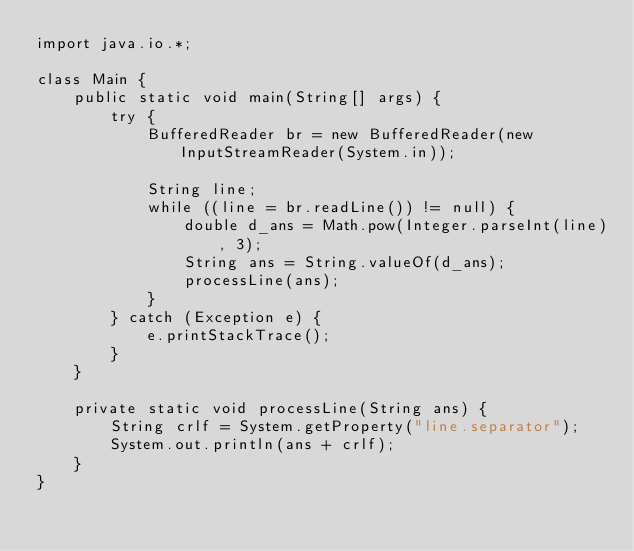Convert code to text. <code><loc_0><loc_0><loc_500><loc_500><_Java_>import java.io.*;

class Main {
    public static void main(String[] args) {
        try {
            BufferedReader br = new BufferedReader(new InputStreamReader(System.in));

            String line; 
            while ((line = br.readLine()) != null) {
                double d_ans = Math.pow(Integer.parseInt(line), 3);
                String ans = String.valueOf(d_ans);
                processLine(ans);
            }
        } catch (Exception e) {
            e.printStackTrace();
        }
    }

    private static void processLine(String ans) {
        String crlf = System.getProperty("line.separator");
        System.out.println(ans + crlf);
    }
}</code> 